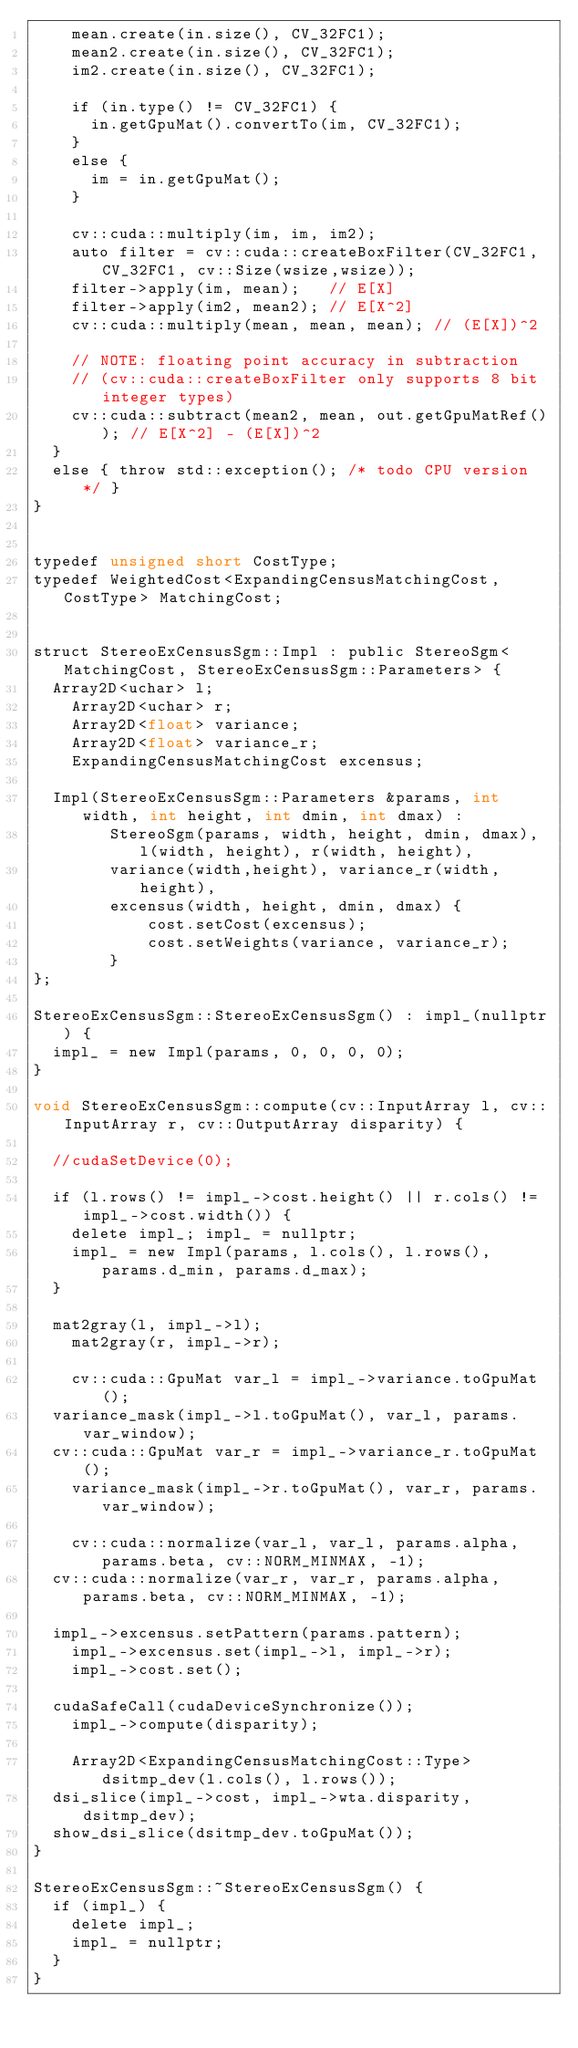Convert code to text. <code><loc_0><loc_0><loc_500><loc_500><_Cuda_>		mean.create(in.size(), CV_32FC1);
		mean2.create(in.size(), CV_32FC1);
		im2.create(in.size(), CV_32FC1);

		if (in.type() != CV_32FC1) {
			in.getGpuMat().convertTo(im, CV_32FC1);
		}
		else {
			im = in.getGpuMat();
		}

		cv::cuda::multiply(im, im, im2);
		auto filter = cv::cuda::createBoxFilter(CV_32FC1, CV_32FC1, cv::Size(wsize,wsize));
		filter->apply(im, mean);   // E[X]
		filter->apply(im2, mean2); // E[X^2]
		cv::cuda::multiply(mean, mean, mean); // (E[X])^2

		// NOTE: floating point accuracy in subtraction
		// (cv::cuda::createBoxFilter only supports 8 bit integer types)
		cv::cuda::subtract(mean2, mean, out.getGpuMatRef()); // E[X^2] - (E[X])^2
	}
	else { throw std::exception(); /* todo CPU version */ }
}


typedef unsigned short CostType;
typedef WeightedCost<ExpandingCensusMatchingCost, CostType> MatchingCost;


struct StereoExCensusSgm::Impl : public StereoSgm<MatchingCost, StereoExCensusSgm::Parameters> {
	Array2D<uchar> l;
    Array2D<uchar> r;
    Array2D<float> variance;
    Array2D<float> variance_r;
    ExpandingCensusMatchingCost excensus;

	Impl(StereoExCensusSgm::Parameters &params, int width, int height, int dmin, int dmax) :
        StereoSgm(params, width, height, dmin, dmax), l(width, height), r(width, height),
        variance(width,height), variance_r(width,height),
        excensus(width, height, dmin, dmax) {
            cost.setCost(excensus);
            cost.setWeights(variance, variance_r);
        }
};

StereoExCensusSgm::StereoExCensusSgm() : impl_(nullptr) {
	impl_ = new Impl(params, 0, 0, 0, 0);
}

void StereoExCensusSgm::compute(cv::InputArray l, cv::InputArray r, cv::OutputArray disparity) {

	//cudaSetDevice(0);

	if (l.rows() != impl_->cost.height() || r.cols() != impl_->cost.width()) {
		delete impl_; impl_ = nullptr;
		impl_ = new Impl(params, l.cols(), l.rows(), params.d_min, params.d_max);
	}

	mat2gray(l, impl_->l);
    mat2gray(r, impl_->r);
    
    cv::cuda::GpuMat var_l = impl_->variance.toGpuMat();
	variance_mask(impl_->l.toGpuMat(), var_l, params.var_window);
	cv::cuda::GpuMat var_r = impl_->variance_r.toGpuMat();
    variance_mask(impl_->r.toGpuMat(), var_r, params.var_window);
    
    cv::cuda::normalize(var_l, var_l, params.alpha, params.beta, cv::NORM_MINMAX, -1);
	cv::cuda::normalize(var_r, var_r, params.alpha, params.beta, cv::NORM_MINMAX, -1);

	impl_->excensus.setPattern(params.pattern);
    impl_->excensus.set(impl_->l, impl_->r);
    impl_->cost.set();

	cudaSafeCall(cudaDeviceSynchronize());
    impl_->compute(disparity);
    
    Array2D<ExpandingCensusMatchingCost::Type> dsitmp_dev(l.cols(), l.rows());
	dsi_slice(impl_->cost, impl_->wta.disparity, dsitmp_dev);
	show_dsi_slice(dsitmp_dev.toGpuMat());
}

StereoExCensusSgm::~StereoExCensusSgm() {
	if (impl_) {
		delete impl_;
		impl_ = nullptr;
	}
}
</code> 